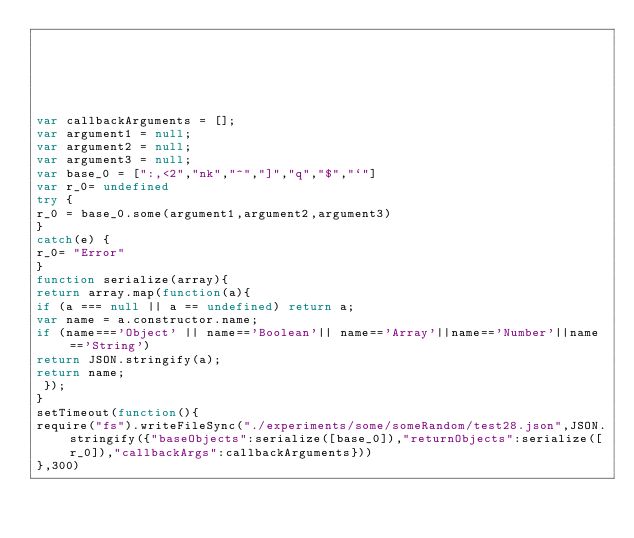<code> <loc_0><loc_0><loc_500><loc_500><_JavaScript_>





var callbackArguments = [];
var argument1 = null;
var argument2 = null;
var argument3 = null;
var base_0 = [":,<2","nk","^","]","q","$","`"]
var r_0= undefined
try {
r_0 = base_0.some(argument1,argument2,argument3)
}
catch(e) {
r_0= "Error"
}
function serialize(array){
return array.map(function(a){
if (a === null || a == undefined) return a;
var name = a.constructor.name;
if (name==='Object' || name=='Boolean'|| name=='Array'||name=='Number'||name=='String')
return JSON.stringify(a);
return name;
 });
}
setTimeout(function(){
require("fs").writeFileSync("./experiments/some/someRandom/test28.json",JSON.stringify({"baseObjects":serialize([base_0]),"returnObjects":serialize([r_0]),"callbackArgs":callbackArguments}))
},300)</code> 